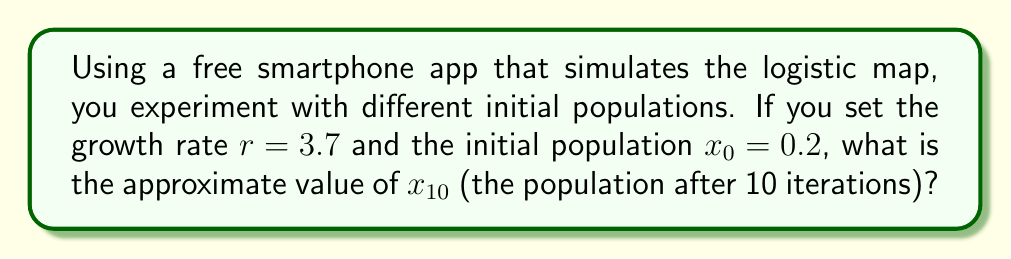Give your solution to this math problem. To solve this problem, we need to use the logistic map equation and iterate it 10 times. The logistic map is given by:

$$x_{n+1} = rx_n(1-x_n)$$

Where $r$ is the growth rate and $x_n$ is the population at step $n$.

Let's calculate step by step:

1) $x_1 = 3.7 \cdot 0.2 \cdot (1-0.2) = 0.592$
2) $x_2 = 3.7 \cdot 0.592 \cdot (1-0.592) = 0.892$
3) $x_3 = 3.7 \cdot 0.892 \cdot (1-0.892) = 0.357$
4) $x_4 = 3.7 \cdot 0.357 \cdot (1-0.357) = 0.849$
5) $x_5 = 3.7 \cdot 0.849 \cdot (1-0.849) = 0.475$
6) $x_6 = 3.7 \cdot 0.475 \cdot (1-0.475) = 0.924$
7) $x_7 = 3.7 \cdot 0.924 \cdot (1-0.924) = 0.260$
8) $x_8 = 3.7 \cdot 0.260 \cdot (1-0.260) = 0.712$
9) $x_9 = 3.7 \cdot 0.712 \cdot (1-0.712) = 0.759$
10) $x_{10} = 3.7 \cdot 0.759 \cdot (1-0.759) = 0.678$

The smartphone app would perform these calculations quickly, allowing you to observe the chaotic behavior of the system over multiple iterations.
Answer: $x_{10} \approx 0.678$ 